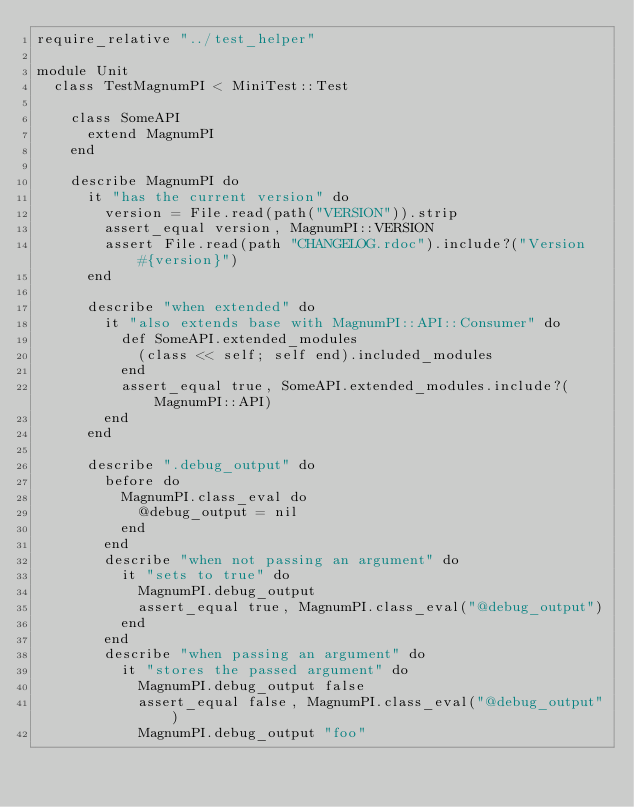Convert code to text. <code><loc_0><loc_0><loc_500><loc_500><_Ruby_>require_relative "../test_helper"

module Unit
  class TestMagnumPI < MiniTest::Test

    class SomeAPI
      extend MagnumPI
    end

    describe MagnumPI do
      it "has the current version" do
        version = File.read(path("VERSION")).strip
        assert_equal version, MagnumPI::VERSION
        assert File.read(path "CHANGELOG.rdoc").include?("Version #{version}")
      end

      describe "when extended" do
        it "also extends base with MagnumPI::API::Consumer" do
          def SomeAPI.extended_modules
            (class << self; self end).included_modules
          end
          assert_equal true, SomeAPI.extended_modules.include?(MagnumPI::API)
        end
      end

      describe ".debug_output" do
        before do
          MagnumPI.class_eval do
            @debug_output = nil
          end
        end
        describe "when not passing an argument" do
          it "sets to true" do
            MagnumPI.debug_output
            assert_equal true, MagnumPI.class_eval("@debug_output")
          end
        end
        describe "when passing an argument" do
          it "stores the passed argument" do
            MagnumPI.debug_output false
            assert_equal false, MagnumPI.class_eval("@debug_output")
            MagnumPI.debug_output "foo"</code> 